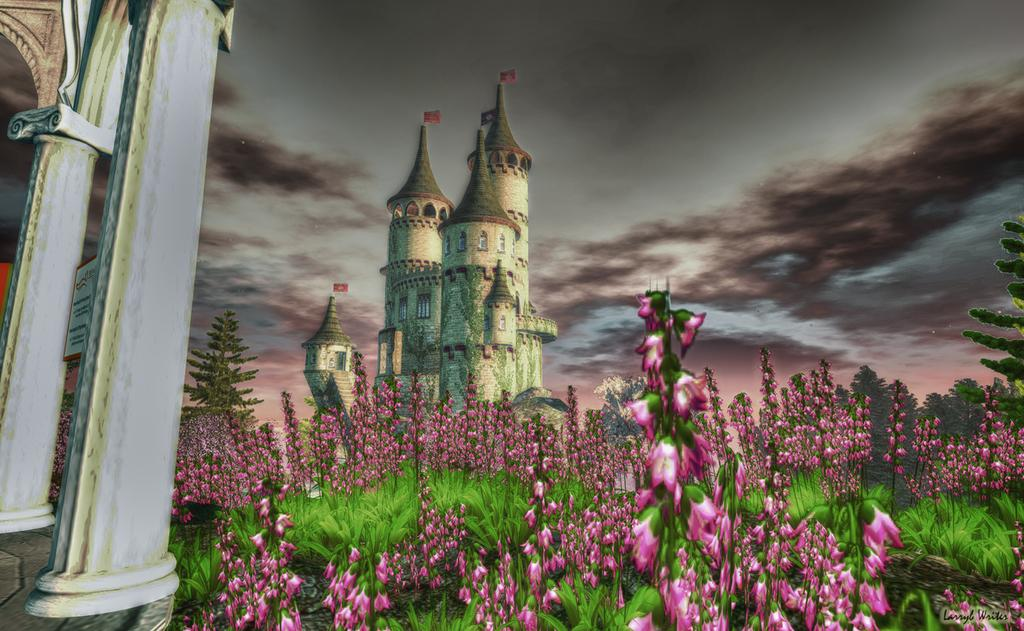What type of plants can be seen in the front of the image? There are many flower plants in the front of the image. What type of structure is visible in the background of the image? There is a castle in the background of the image. What architectural feature can be seen on the left side of the image? There are pillars on the left side of the image. What part of the natural environment is visible in the image? The sky is visible in the image. What can be observed in the sky? Clouds are present in the sky. How is the image created? The image appears to be a painting. Where is the lake located in the image? There is no lake present in the image. What type of thread is used to create the castle in the image? The image is a painting, not a threaded creation, so there is no thread used in the image. 